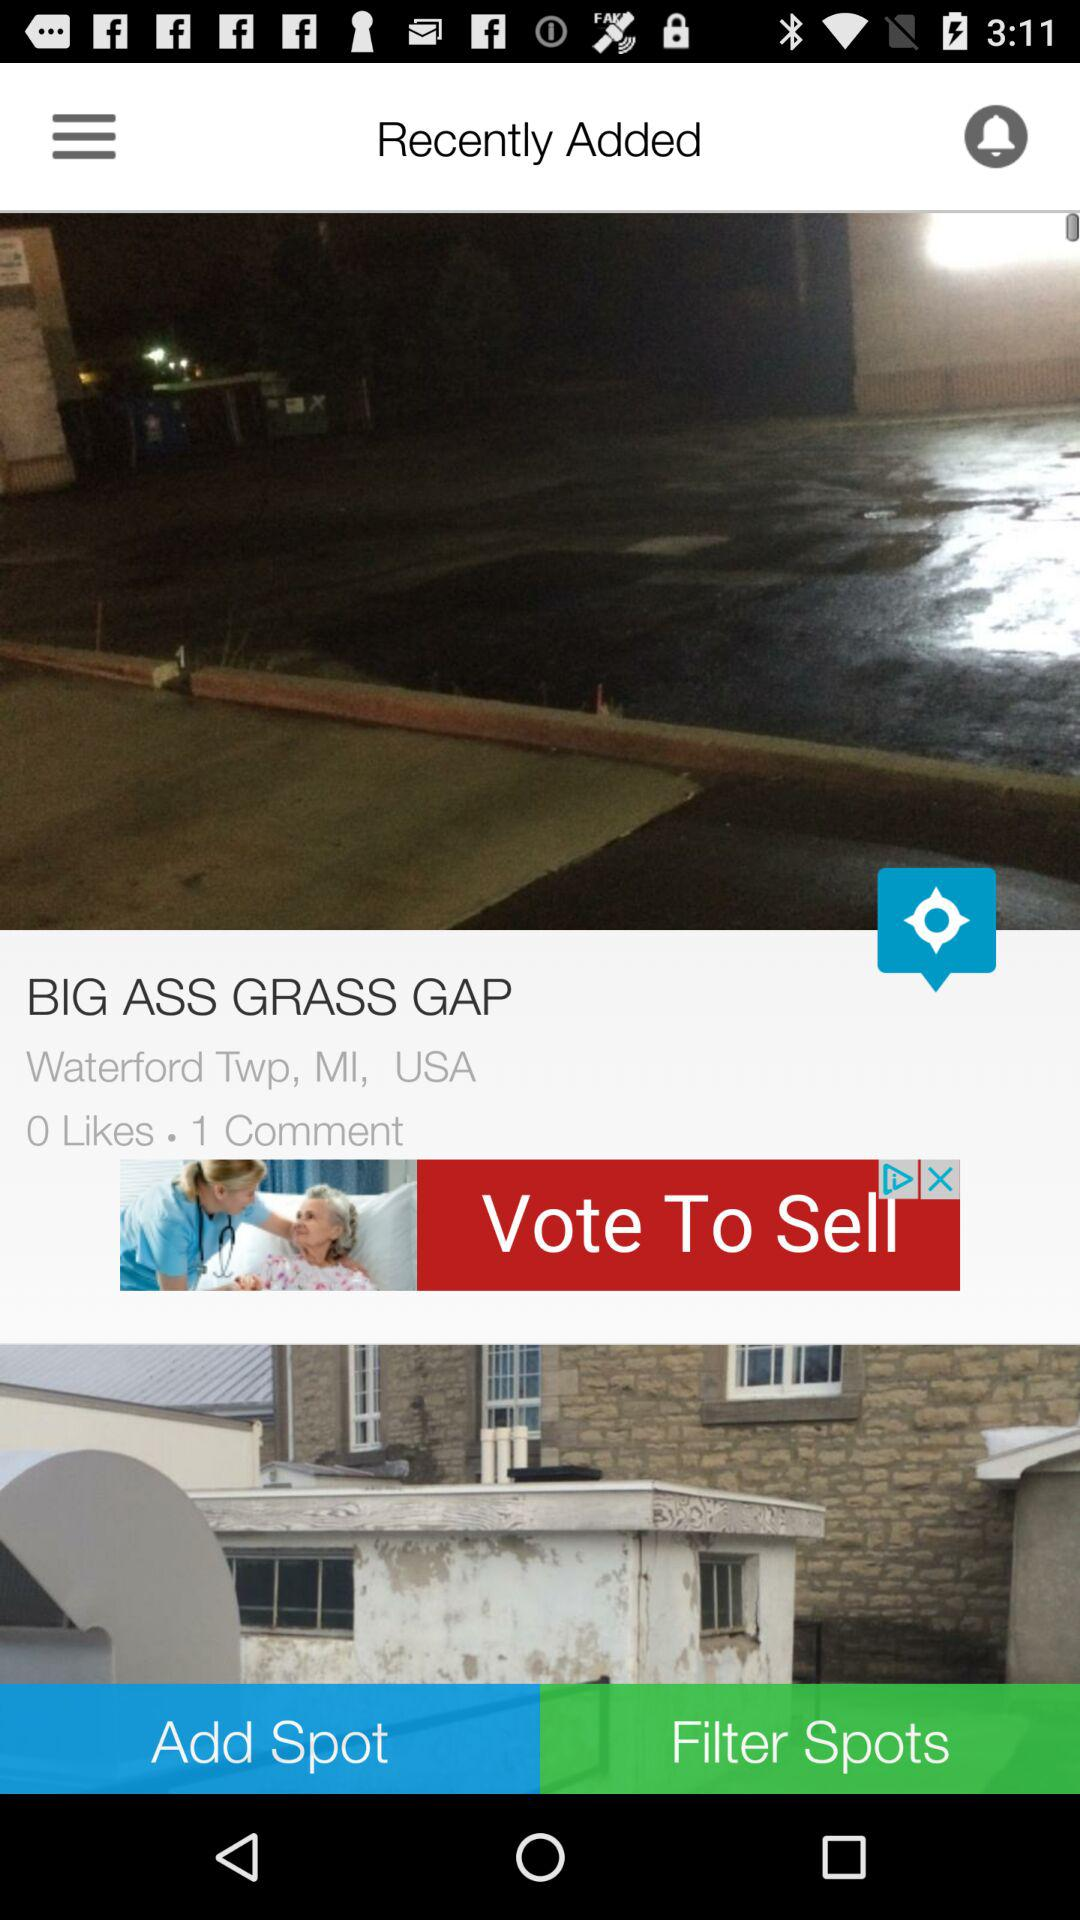How many likes and comments did the post get? The post got 0 likes and 1 comment. 